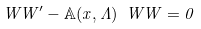Convert formula to latex. <formula><loc_0><loc_0><loc_500><loc_500>\ W W ^ { \prime } - { \mathbb { A } } ( x , \Lambda ) \ W W = 0</formula> 